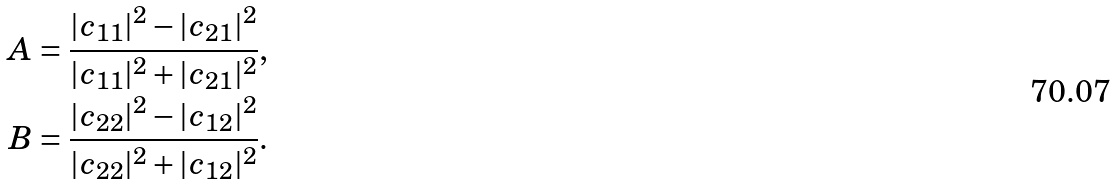<formula> <loc_0><loc_0><loc_500><loc_500>A = \frac { | c _ { 1 1 } | ^ { 2 } - | c _ { 2 1 } | ^ { 2 } } { | c _ { 1 1 } | ^ { 2 } + | c _ { 2 1 } | ^ { 2 } } , \\ B = \frac { | c _ { 2 2 } | ^ { 2 } - | c _ { 1 2 } | ^ { 2 } } { | c _ { 2 2 } | ^ { 2 } + | c _ { 1 2 } | ^ { 2 } } .</formula> 